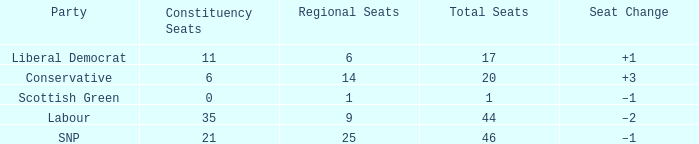What is the full number of Total Seats with a constituency seat number bigger than 0 with the Liberal Democrat party, and the Regional seat number is smaller than 6? None. 